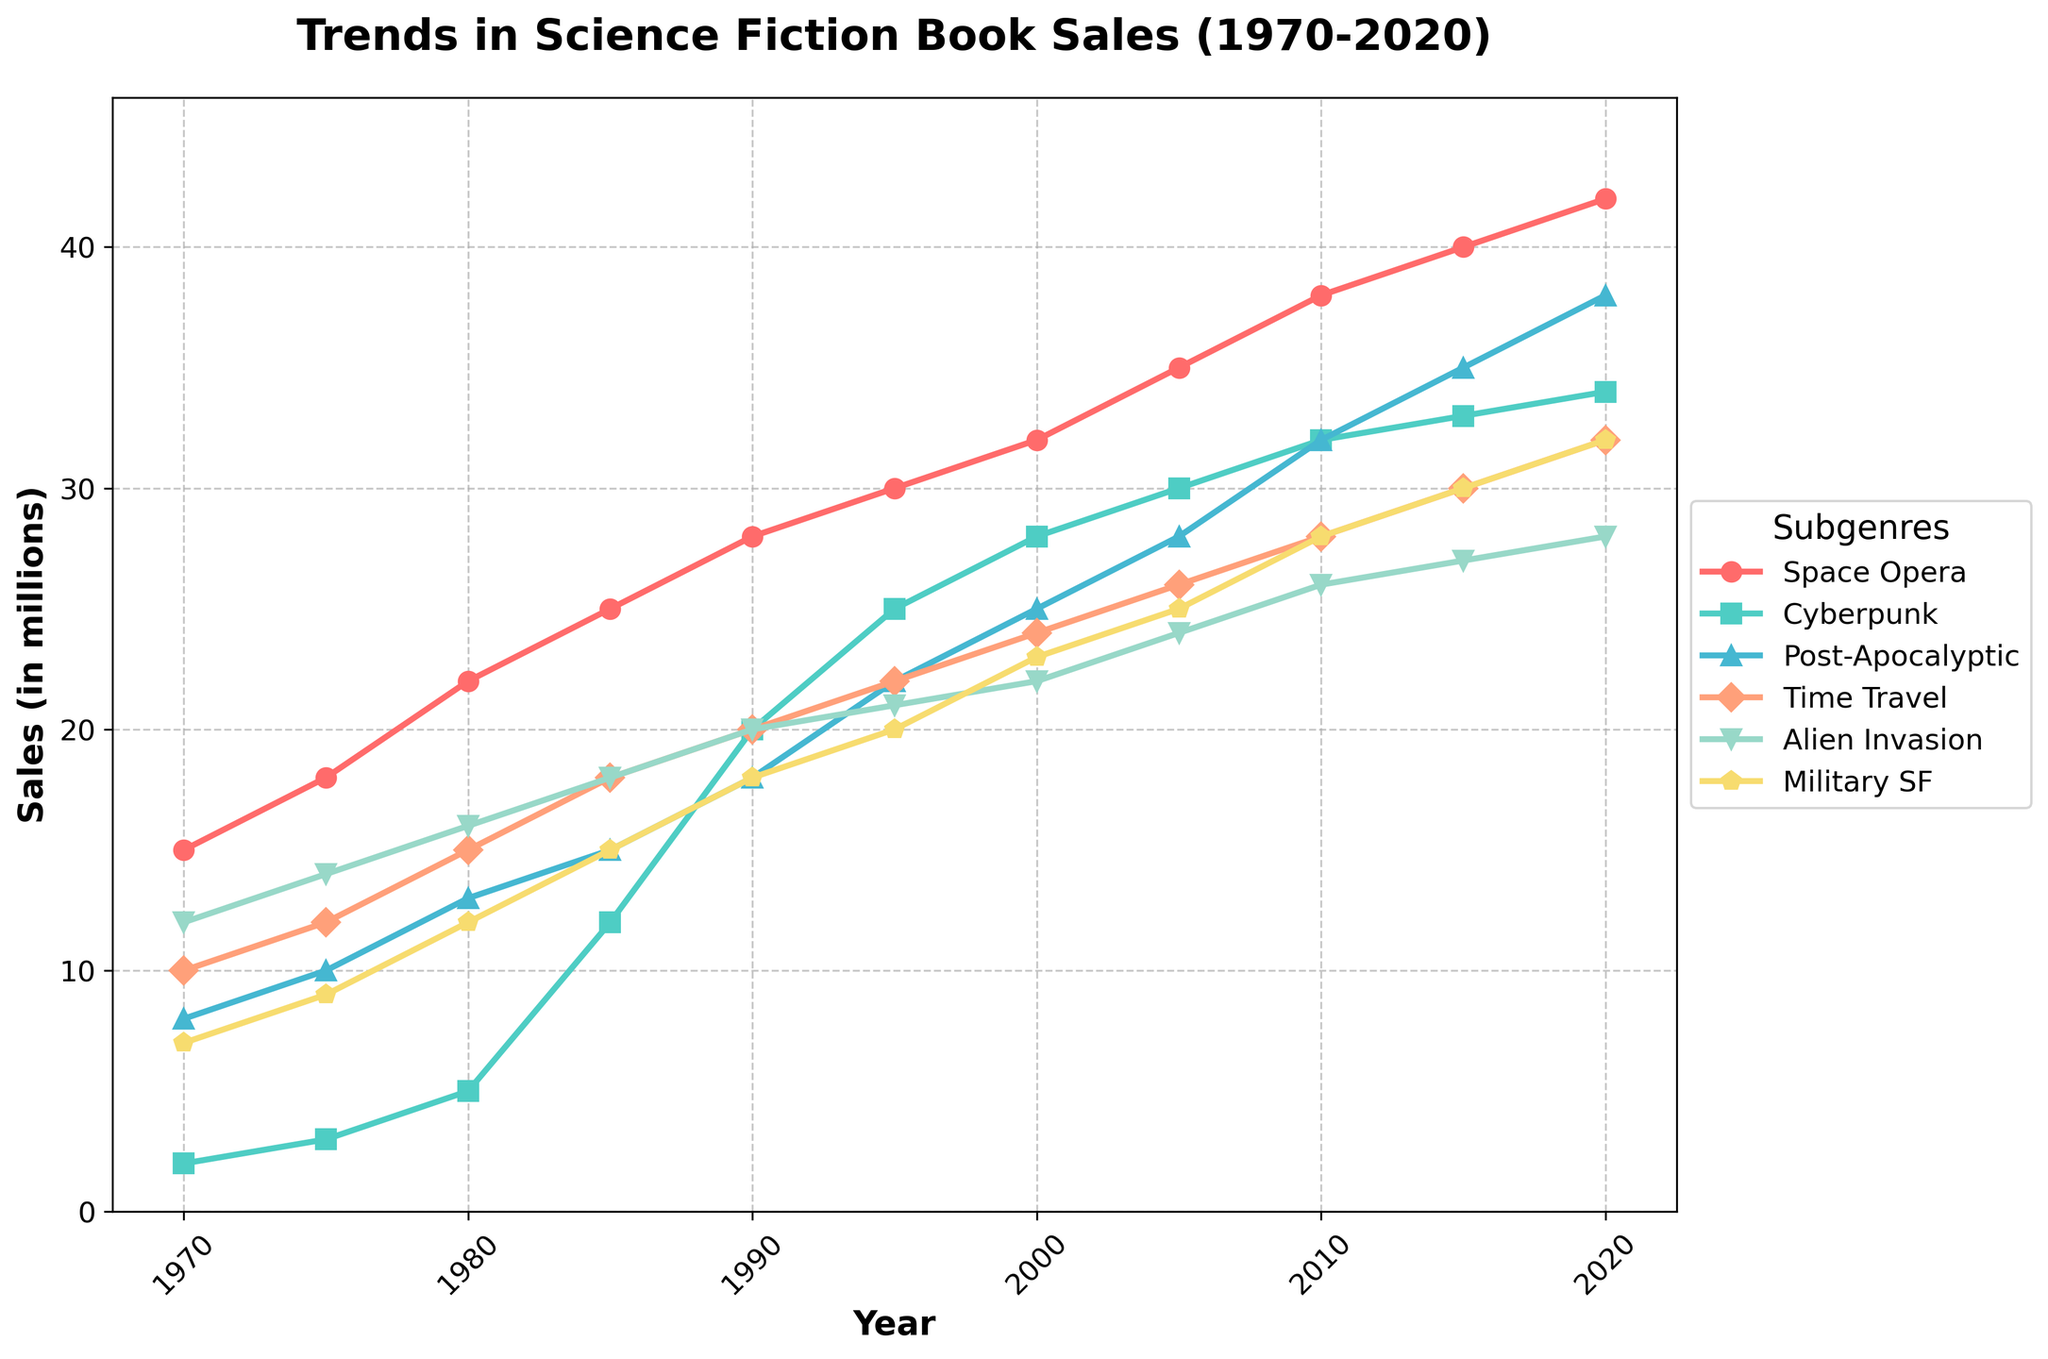what is the subgenre with the highest sales in 2020? To find the subgenre with the highest sales in 2020, look at the final year on the x-axis (2020) and identify which line reaches the highest point on the y-axis.
Answer: Space Opera Between 1970 and 2020, which subgenre showed the greatest increase in sales? To determine which subgenre showed the greatest increase, compare the difference in sales from 1970 to 2020 for each subgenre. Space Opera increased from 15 to 42, which is an increase of 27 million.
Answer: Space Opera What is the average sales of Cyberpunk books between 1970 and 2020? Add up the sales of Cyberpunk over the years: 2+3+5+12+20+25+28+30+32+33+34=224. There are 11 data points, so the average is 224/11.
Answer: 20.36 (approximately) How did the sales of Post-Apocalyptic compare to Time Travel in 2000? Look at the sales numbers for both Post-Apocalyptic and Time Travel in the year 2000. Post-Apocalyptic sold 25 million books, while Time Travel sold 24 million.
Answer: Post-Apocalyptic is slightly higher Among the subgenres, which one had the least change in sales from 1970 to 2020? To find the subgenre with the least change in sales, compare the difference from 1970 to 2020 for each one. Military SF had the smallest change, going from 7 to 32 which is an increase of 25 million.
Answer: Military SF Compare the sales of Space Opera and Alien Invasion in 1995. In 1995, Space Opera had 30 million sales and Alien Invasion had 21 million. Comparing these values, Space Opera had higher sales.
Answer: Space Opera had higher sales Which subgenres had sales closer to each other in 2015? Look at the sales numbers for all subgenres in 2015 and compare their values. Military SF and Alien Invasion have close sales at 30 million and 27 million respectively.
Answer: Military SF and Alien Invasion Between Cyberpunk and Military SF, which subgenre saw a more rapid increase in sales from 1970 to 1985? From 1970 to 1985, Cyberpunk increased from 2 to 12 (10 million increase), and Military SF increased from 7 to 15 (8 million increase). Cyberpunk had a more rapid increase.
Answer: Cyberpunk What was the total sales of Alien Invasion, Time Travel, and Cyberpunk subgenres in 2010? Add the sales of the three subgenres in 2010: Alien Invasion (26) + Time Travel (28) + Cyberpunk (32) = 86 million.
Answer: 86 million 